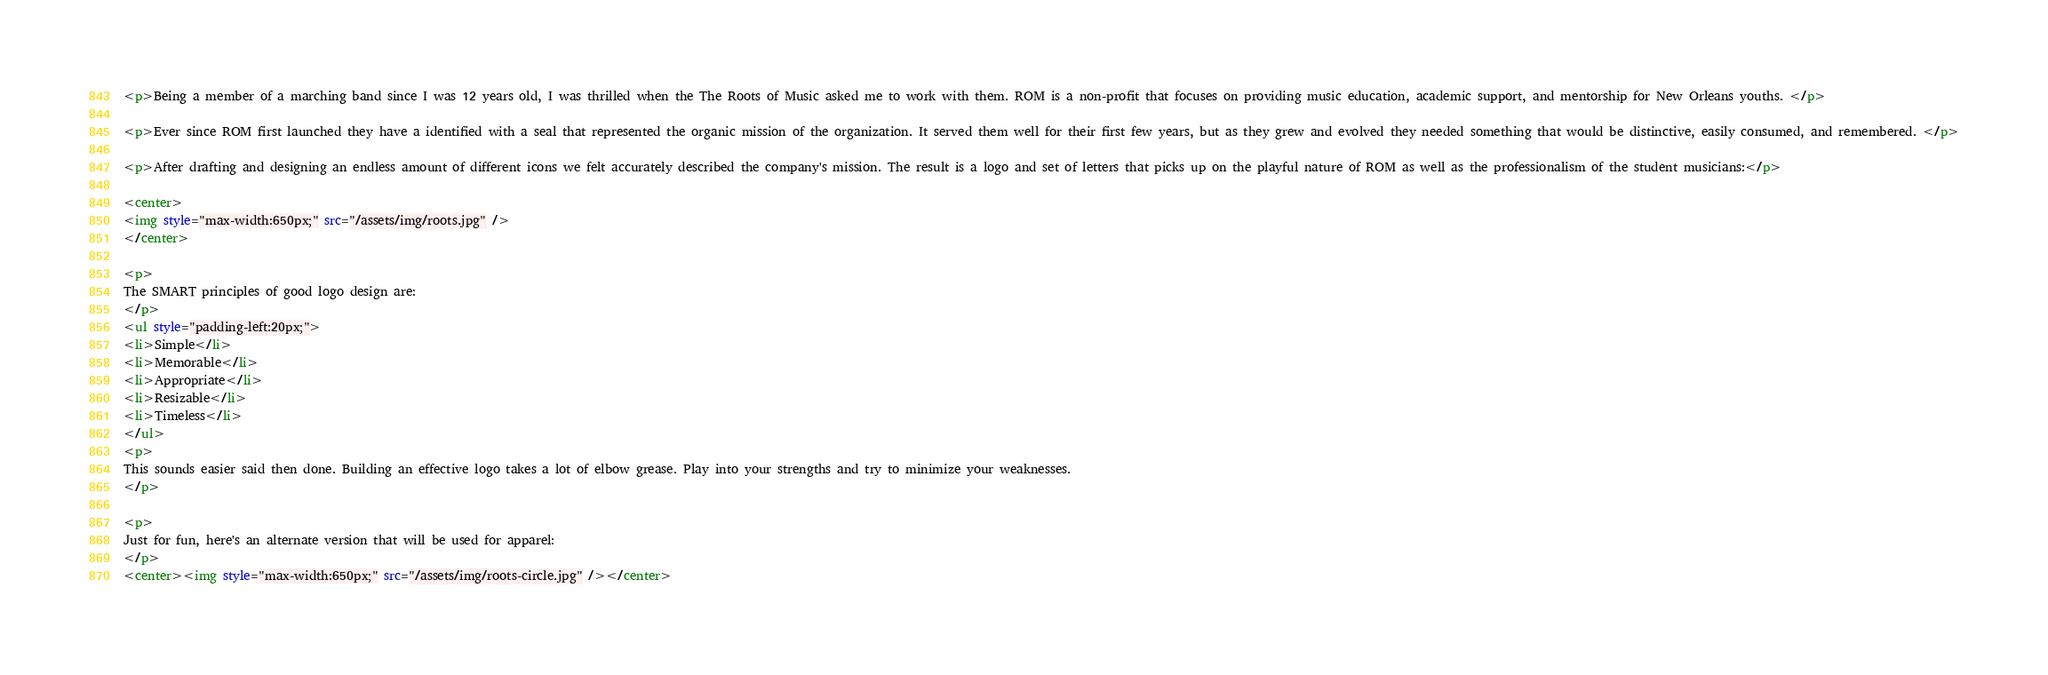Convert code to text. <code><loc_0><loc_0><loc_500><loc_500><_HTML_><p>Being a member of a marching band since I was 12 years old, I was thrilled when the The Roots of Music asked me to work with them. ROM is a non-profit that focuses on providing music education, academic support, and mentorship for New Orleans youths. </p>

<p>Ever since ROM first launched they have a identified with a seal that represented the organic mission of the organization. It served them well for their first few years, but as they grew and evolved they needed something that would be distinctive, easily consumed, and remembered. </p>

<p>After drafting and designing an endless amount of different icons we felt accurately described the company's mission. The result is a logo and set of letters that picks up on the playful nature of ROM as well as the professionalism of the student musicians:</p>

<center>
<img style="max-width:650px;" src="/assets/img/roots.jpg" />
</center>

<p>
The SMART principles of good logo design are:
</p>
<ul style="padding-left:20px;">
<li>Simple</li>
<li>Memorable</li>
<li>Appropriate</li>
<li>Resizable</li>
<li>Timeless</li>
</ul>
<p>
This sounds easier said then done. Building an effective logo takes a lot of elbow grease. Play into your strengths and try to minimize your weaknesses. 
</p>

<p>
Just for fun, here's an alternate version that will be used for apparel:
</p>
<center><img style="max-width:650px;" src="/assets/img/roots-circle.jpg" /></center>
</code> 